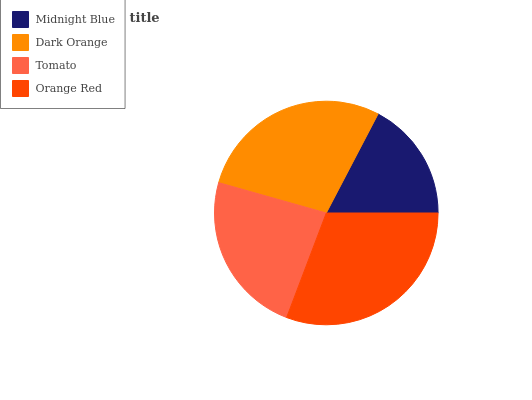Is Midnight Blue the minimum?
Answer yes or no. Yes. Is Orange Red the maximum?
Answer yes or no. Yes. Is Dark Orange the minimum?
Answer yes or no. No. Is Dark Orange the maximum?
Answer yes or no. No. Is Dark Orange greater than Midnight Blue?
Answer yes or no. Yes. Is Midnight Blue less than Dark Orange?
Answer yes or no. Yes. Is Midnight Blue greater than Dark Orange?
Answer yes or no. No. Is Dark Orange less than Midnight Blue?
Answer yes or no. No. Is Dark Orange the high median?
Answer yes or no. Yes. Is Tomato the low median?
Answer yes or no. Yes. Is Orange Red the high median?
Answer yes or no. No. Is Dark Orange the low median?
Answer yes or no. No. 